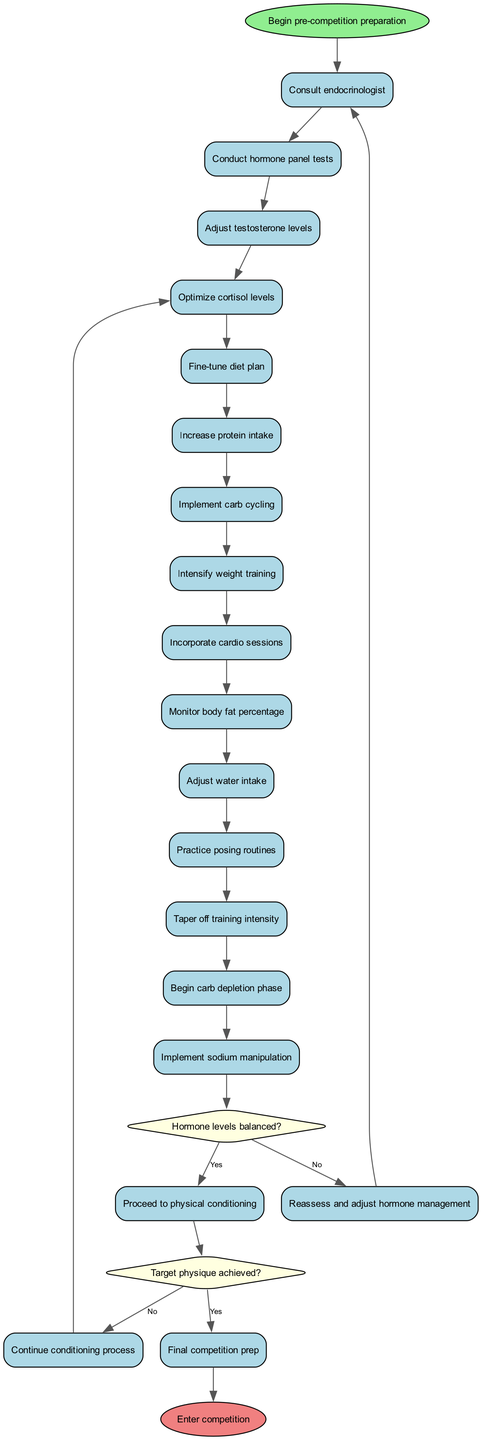What is the starting point of the diagram? The diagram begins at the node labeled "Begin pre-competition preparation." This is indicated as the first node in the activity sequence.
Answer: Begin pre-competition preparation How many decision nodes are present in the diagram? There are two decision nodes in the diagram, each representing a decision point based on specific conditions regarding hormone levels and target physique.
Answer: 2 What is the first activity listed in the diagram? The first activity listed is "Consult endocrinologist," which follows the start node. This indicates the initial step in the preparation process.
Answer: Consult endocrinologist What happens if hormone levels are not balanced? If hormone levels are not balanced, the process goes to the path labeled "Reassess and adjust hormone management," indicating a need to adjust before proceeding to physical conditioning.
Answer: Reassess and adjust hormone management What is the final outcome if the target physique is achieved? If the target physique is achieved, the next step leads to "Final competition prep," indicating that no further conditioning is needed at that point.
Answer: Final competition prep What activity comes before the decision about hormone levels? The activity that comes just before the decision about hormone levels (the first decision node) is "Conduct hormone panel tests." This is where information about hormone levels is obtained before making decisions.
Answer: Conduct hormone panel tests If the answer to the fist decision is "Yes," what is the next phase? If the answer to the first decision of whether hormone levels are balanced is "Yes," the process moves to "Proceed to physical conditioning." This indicates that after achieving hormone balance, focus shifts to physical conditioning.
Answer: Proceed to physical conditioning How many activities are listed after the initial activity? There are 12 activities listed after the initial activity of "Consult endocrinologist." The sequence includes a variety of steps leading to physical conditioning and final preparations.
Answer: 12 